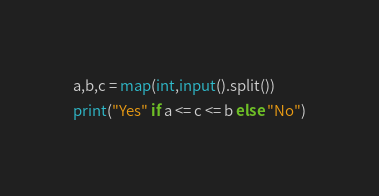<code> <loc_0><loc_0><loc_500><loc_500><_Python_>a,b,c = map(int,input().split())
print("Yes" if a <= c <= b else "No")</code> 